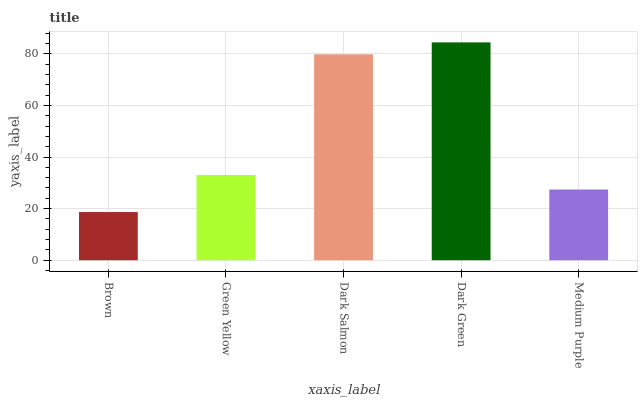Is Brown the minimum?
Answer yes or no. Yes. Is Dark Green the maximum?
Answer yes or no. Yes. Is Green Yellow the minimum?
Answer yes or no. No. Is Green Yellow the maximum?
Answer yes or no. No. Is Green Yellow greater than Brown?
Answer yes or no. Yes. Is Brown less than Green Yellow?
Answer yes or no. Yes. Is Brown greater than Green Yellow?
Answer yes or no. No. Is Green Yellow less than Brown?
Answer yes or no. No. Is Green Yellow the high median?
Answer yes or no. Yes. Is Green Yellow the low median?
Answer yes or no. Yes. Is Dark Green the high median?
Answer yes or no. No. Is Dark Green the low median?
Answer yes or no. No. 